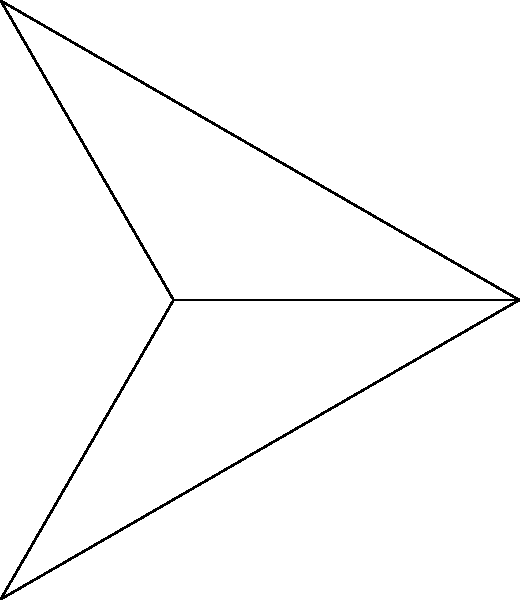In a home theater setup, three speakers are placed in an equilateral triangle formation with the listener at the center. If the distance between the listener and each speaker is 7 meters, and the angle between any two adjacent speakers is 120°, what is the distance between two adjacent speakers? Let's approach this step-by-step:

1) The speakers form an equilateral triangle, with the listener at the center of the circle circumscribing this triangle.

2) The radius of this circle is 7 meters (the distance from the listener to each speaker).

3) The angle between any two adjacent speakers is 120°. This means that the central angle of the sector formed by two radii to adjacent speakers is also 120°.

4) In a triangle formed by two radii and the chord connecting two adjacent speakers:
   - We know two sides (both radii = 7 m)
   - We know the included angle (120°)

5) We can use the law of cosines to find the length of the third side (the distance between speakers):

   $c^2 = a^2 + b^2 - 2ab \cos(C)$

   Where:
   $c$ is the distance we're looking for
   $a = b = 7$ (the radius)
   $C = 120°$

6) Plugging in the values:

   $c^2 = 7^2 + 7^2 - 2(7)(7) \cos(120°)$

7) Simplify:
   $c^2 = 49 + 49 - 98 \cos(120°)$
   $c^2 = 98 + 49 = 147$

8) Take the square root of both sides:
   $c = \sqrt{147} = 7\sqrt{3}$

Therefore, the distance between any two adjacent speakers is $7\sqrt{3}$ meters.
Answer: $7\sqrt{3}$ meters 